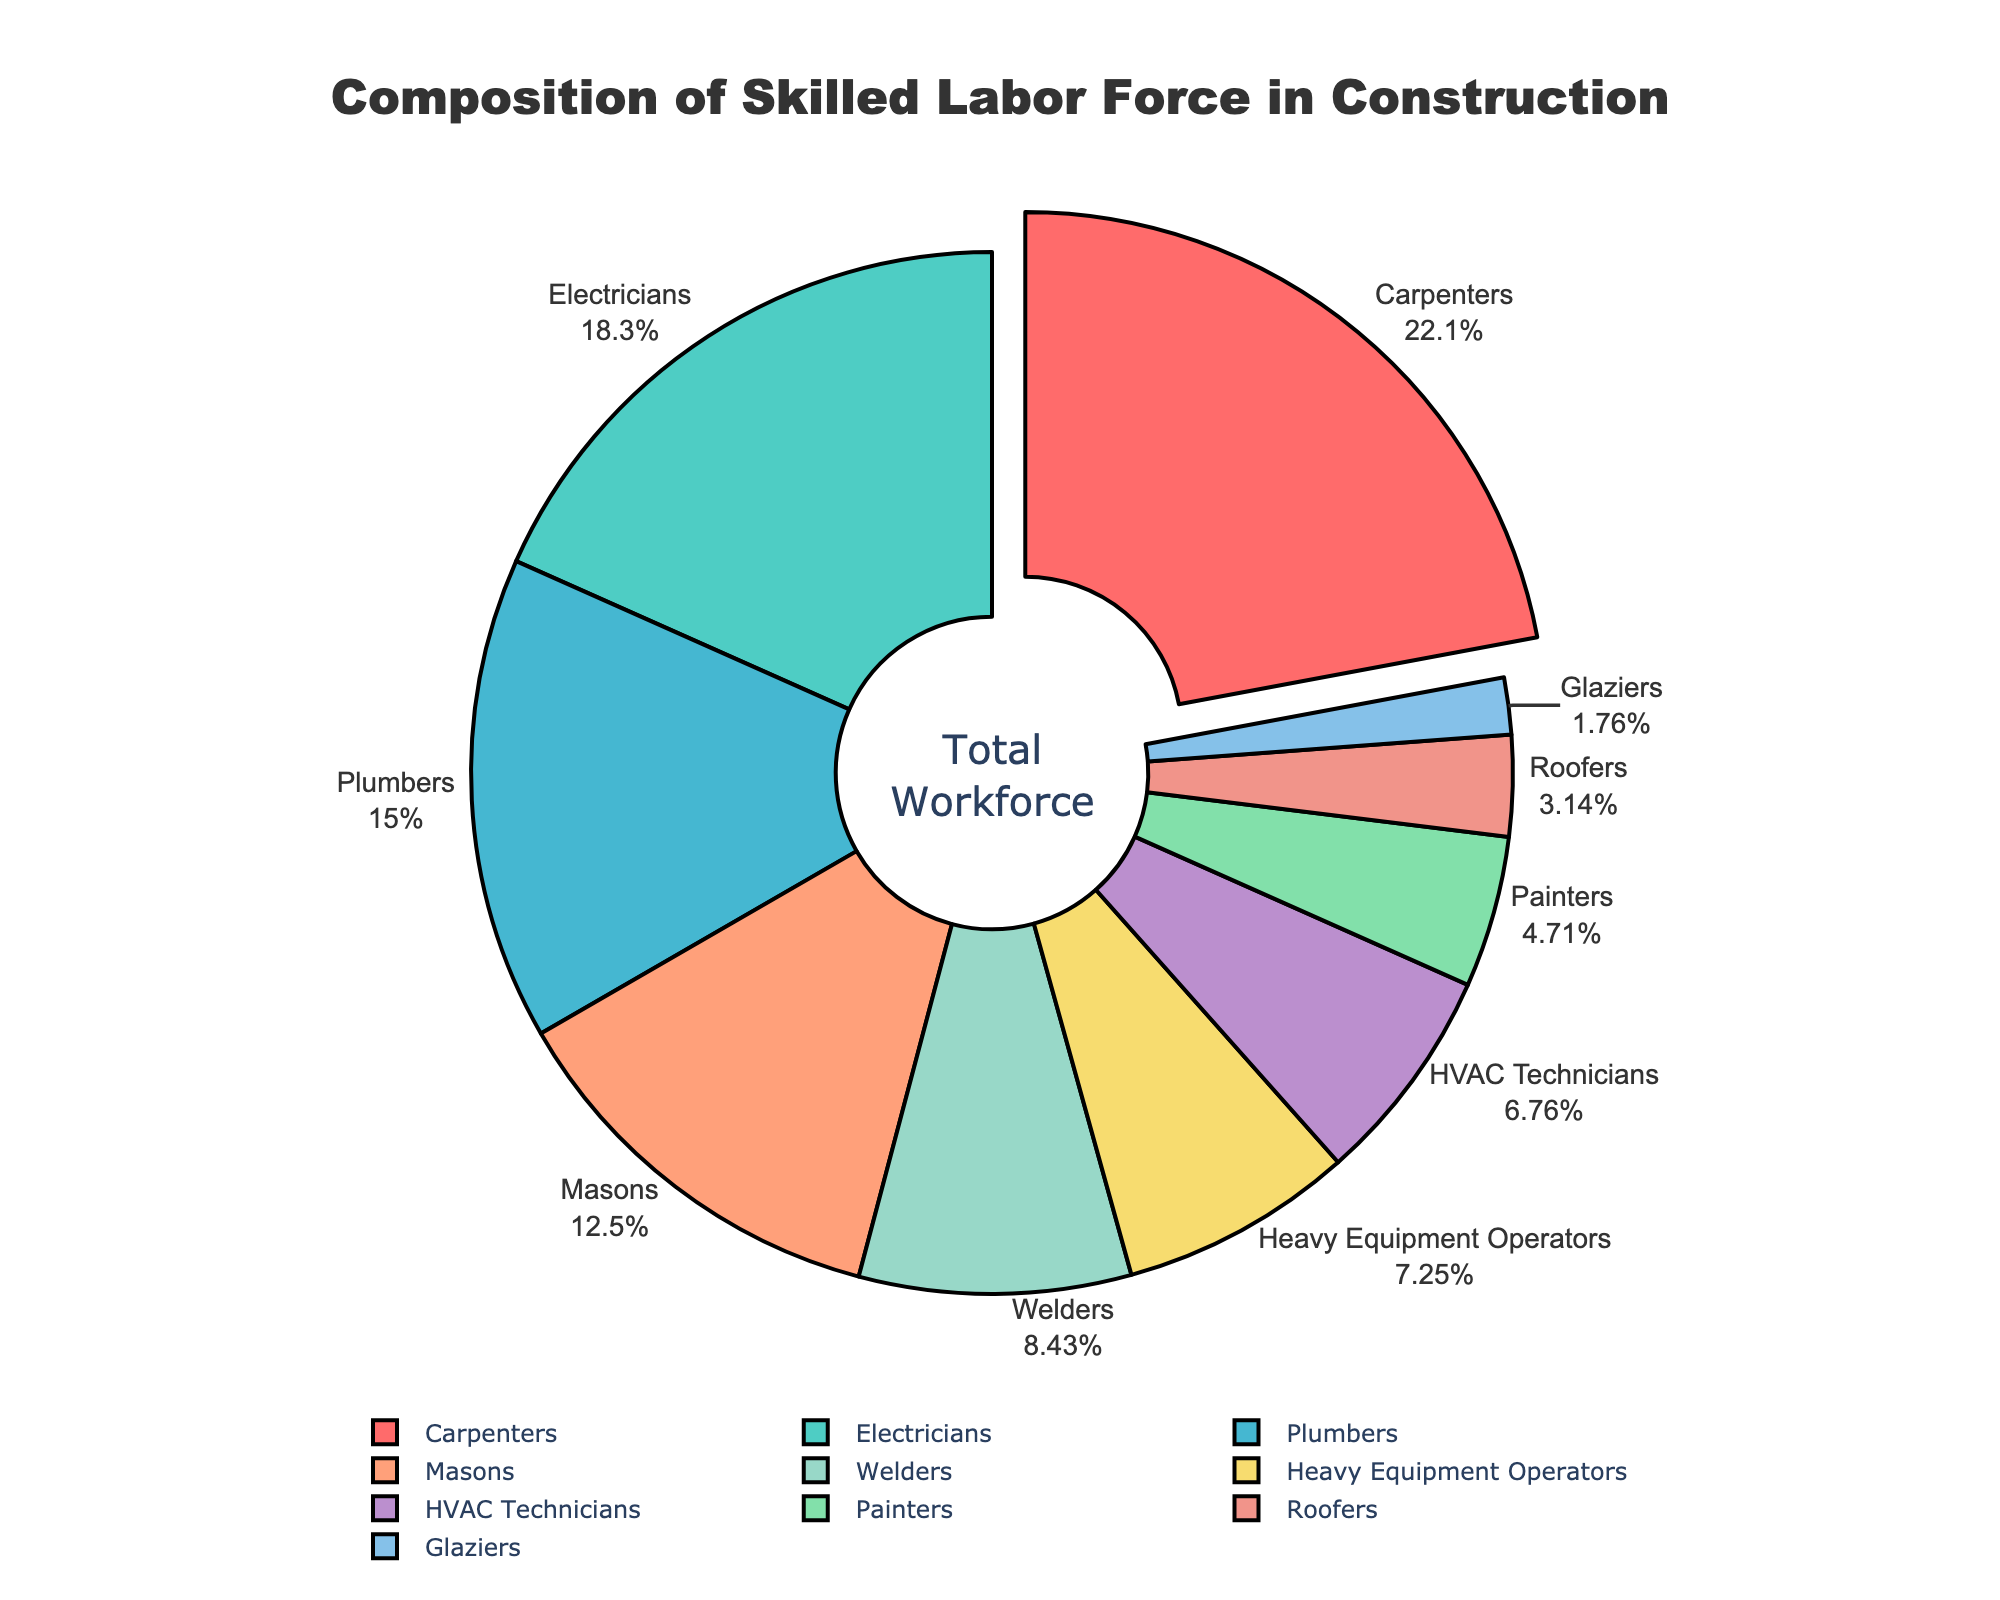Which trade has the highest percentage in the skilled labor force? In the chart, the trade with the highest percentage is highlighted and usually has a pulled-out effect. This is "Carpenters," with 22.5%.
Answer: Carpenters How much more percentage do Electricians have compared to HVAC Technicians? The percentage for Electricians is 18.7%, and for HVAC Technicians, it is 6.9%. The difference is 18.7% - 6.9% = 11.8%.
Answer: 11.8% What is the combined percentage of Plumbers and Masons? The percentage for Plumbers is 15.3%, and for Masons, it is 12.8%. The combined percentage is 15.3% + 12.8% = 28.1%.
Answer: 28.1% Are there more Carpenters or Welders in the skilled labor force? The percentage for Carpenters is 22.5%, and for Welders, it is 8.6%. Carpenters have a higher percentage than Welders.
Answer: Carpenters Which trade has a smaller percentage, Painters or Roofers? The percentage for Painters is 4.8%, and for Roofers, it is 3.2%. Roofers have a smaller percentage than Painters.
Answer: Roofers What is the average percentage of the top four trades by percentage? The top four trades by percentage are Carpenters (22.5%), Electricians (18.7%), Plumbers (15.3%), and Masons (12.8%). The sum is 22.5% + 18.7% + 15.3% + 12.8% = 69.3%. The average is 69.3% / 4 = 17.325%.
Answer: 17.325% How much percentage of the skilled labor force is composed of trades other than Carpenters? Carpenters make up 22.5% of the workforce. The total percentage is 100%, so the percentage of all other trades is 100% - 22.5% = 77.5%.
Answer: 77.5% Which trades fall under the top five categories in the pie chart by percentage? The top five trades by percentage are Carpenters (22.5%), Electricians (18.7%), Plumbers (15.3%), Masons (12.8%), and Welders (8.6%).
Answer: Carpenters, Electricians, Plumbers, Masons, Welders Are there any trades with a percentage less than 5%? If so, which ones? The trades with percentages less than 5% are Painters (4.8%), Roofers (3.2%), and Glaziers (1.8%).
Answer: Painters, Roofers, Glaziers What is the percentage difference between Heavy Equipment Operators and Glaziers? The percentage for Heavy Equipment Operators is 7.4%, and for Glaziers, it is 1.8%. The difference is 7.4% - 1.8% = 5.6%.
Answer: 5.6% 